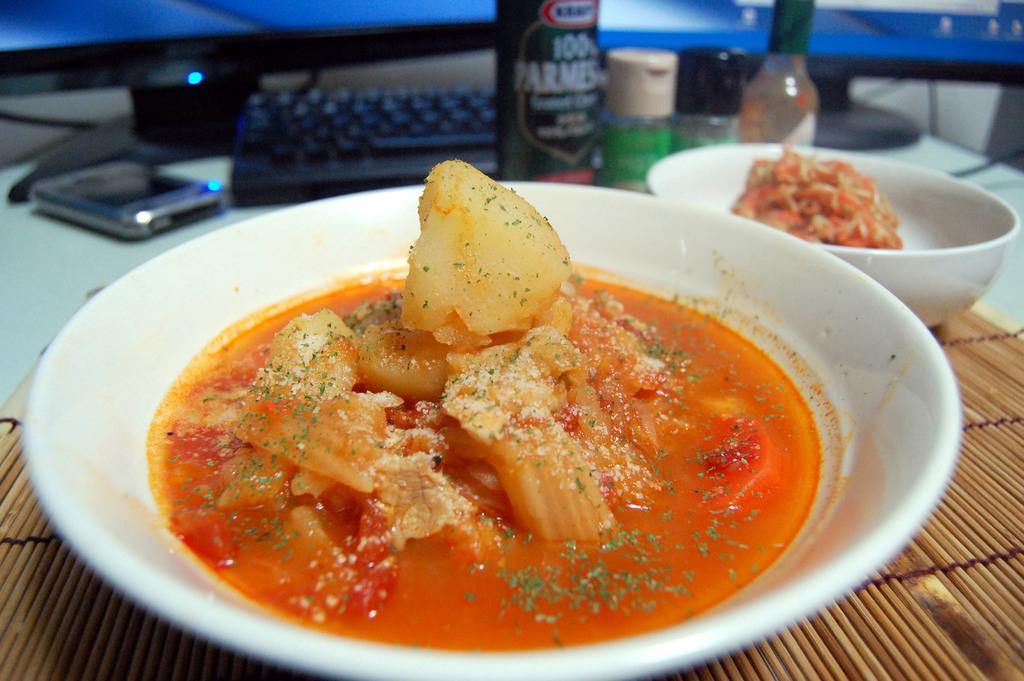In one or two sentences, can you explain what this image depicts? In this picture we can see food in the plate and bowl, beside to the plate we can see few bottles, mobile and a keyboard on the table, and also we can see few monitors. 